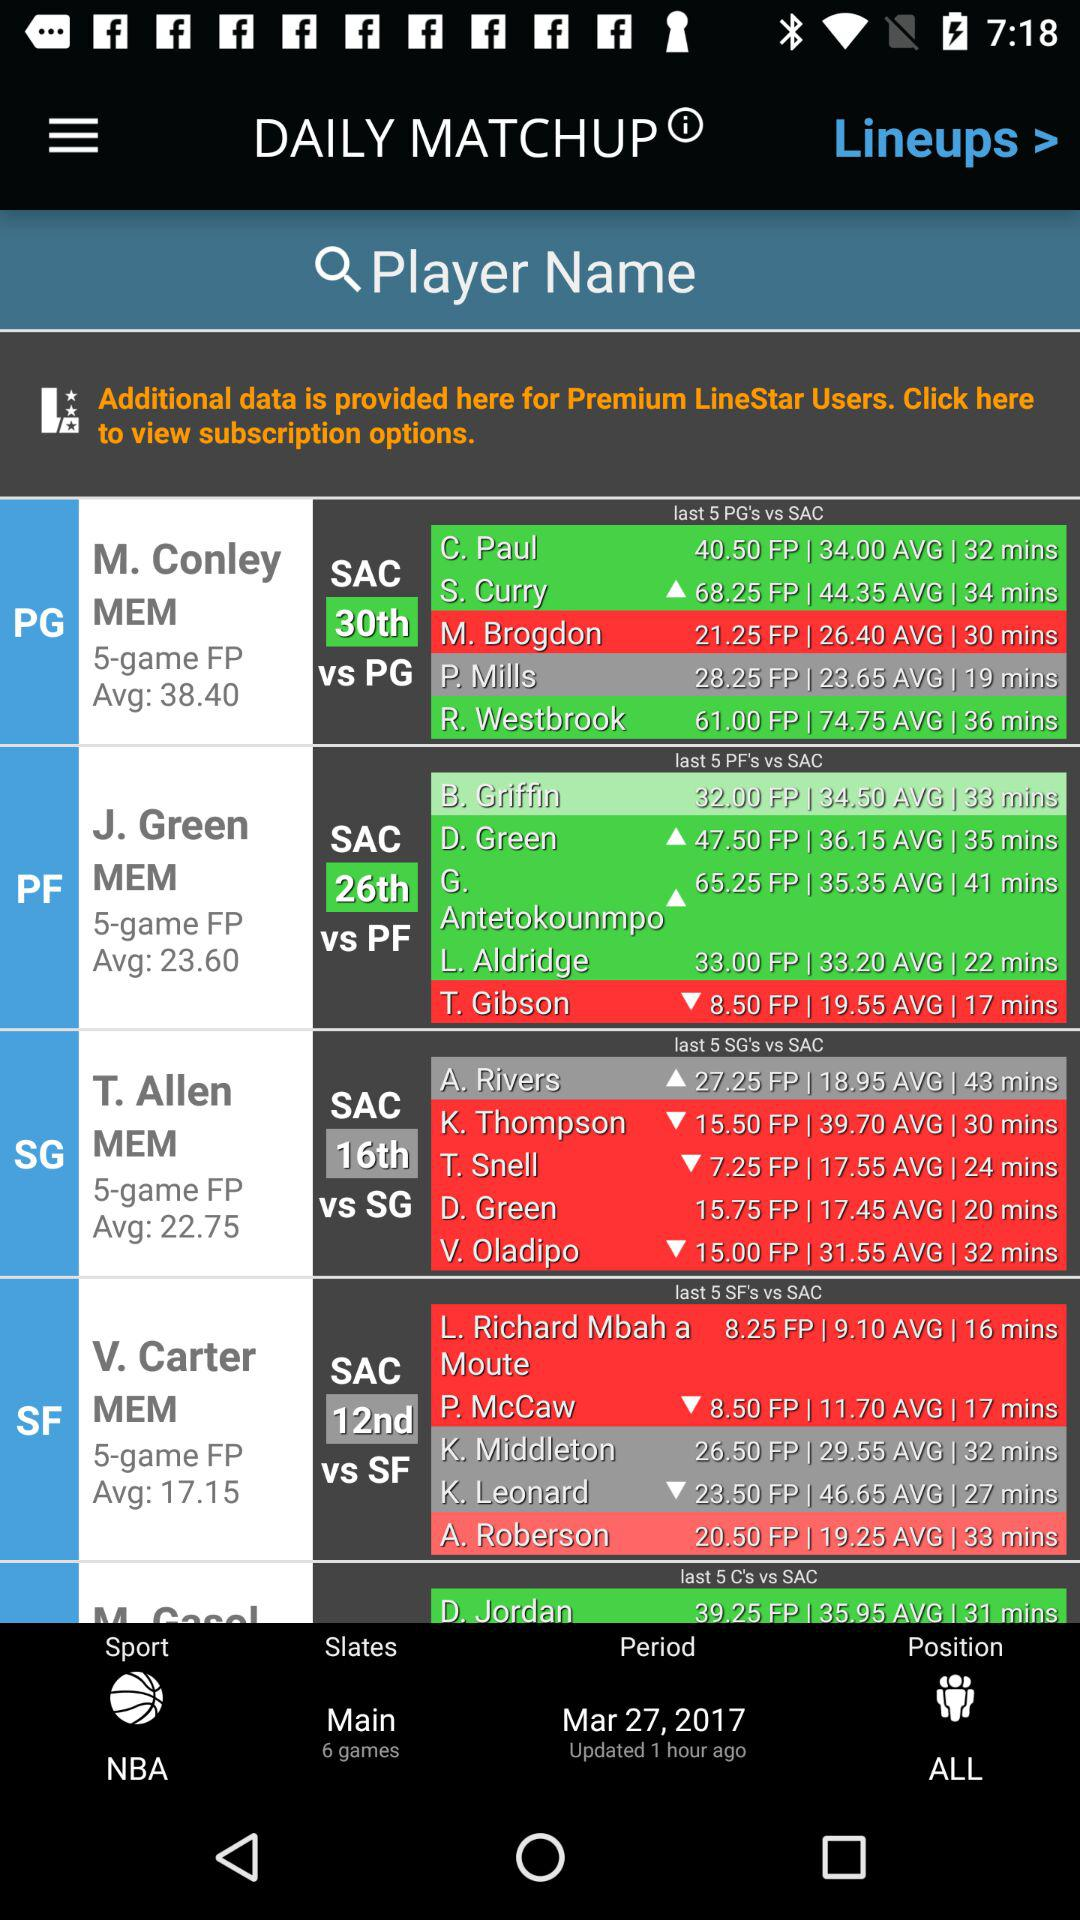What is the FP of C. Paul? The FP of C. Paul is 40.50. 